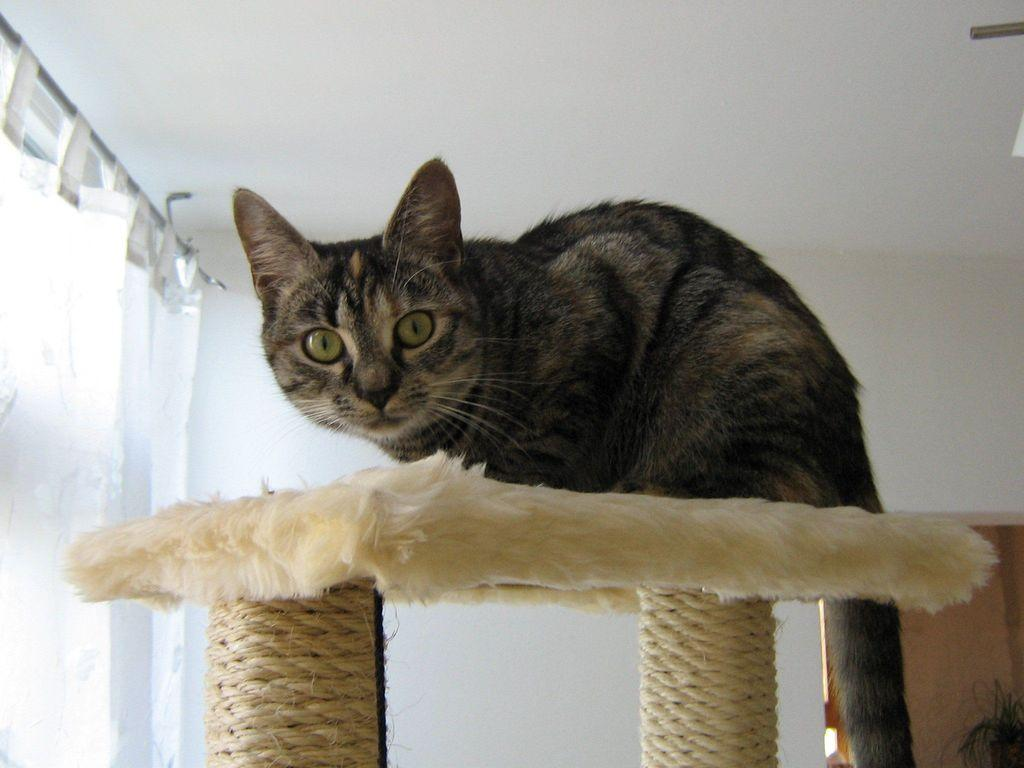What is the color of the object that the cat is on in the image? The object is cream-colored. What type of animal is on the cream-colored object? There is a black and brown cat on the cream-colored object. What can be seen in the background of the image? There is a white curtain and a white wall in the background of the image. What type of bird is flying in front of the cloud in the image? There is no bird or cloud present in the image. 